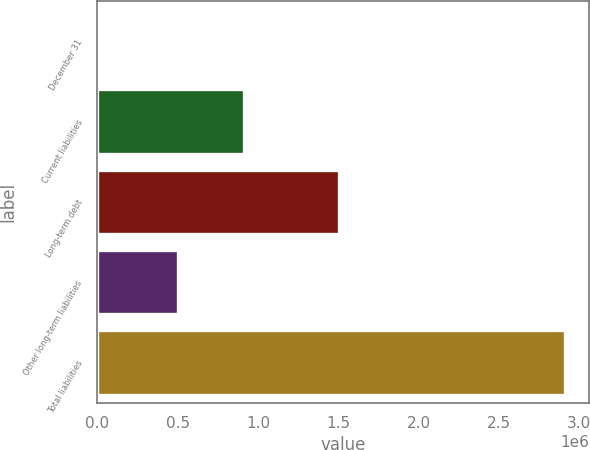<chart> <loc_0><loc_0><loc_500><loc_500><bar_chart><fcel>December 31<fcel>Current liabilities<fcel>Long-term debt<fcel>Other long-term liabilities<fcel>Total liabilities<nl><fcel>2009<fcel>910628<fcel>1.50273e+06<fcel>501334<fcel>2.91469e+06<nl></chart> 